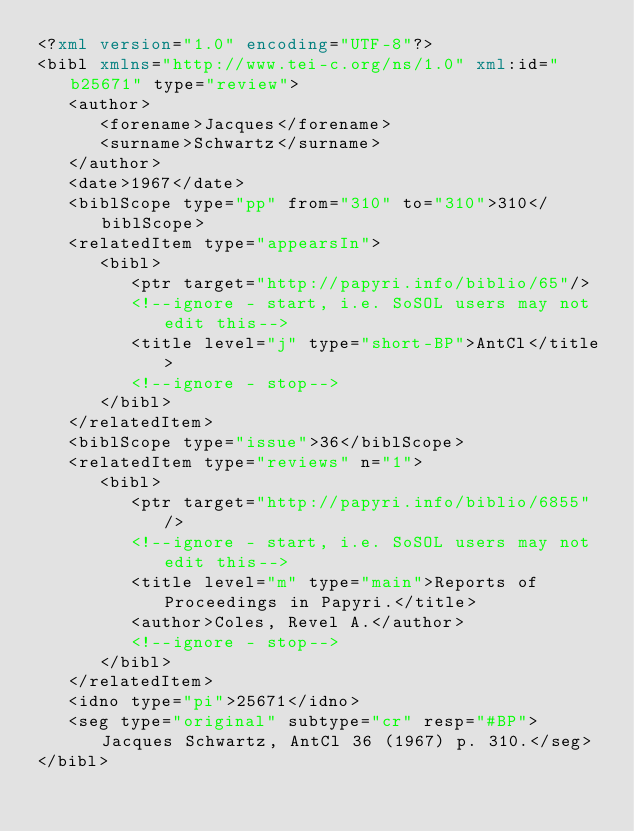Convert code to text. <code><loc_0><loc_0><loc_500><loc_500><_XML_><?xml version="1.0" encoding="UTF-8"?>
<bibl xmlns="http://www.tei-c.org/ns/1.0" xml:id="b25671" type="review">
   <author>
      <forename>Jacques</forename>
      <surname>Schwartz</surname>
   </author>
   <date>1967</date>
   <biblScope type="pp" from="310" to="310">310</biblScope>
   <relatedItem type="appearsIn">
      <bibl>
         <ptr target="http://papyri.info/biblio/65"/>
         <!--ignore - start, i.e. SoSOL users may not edit this-->
         <title level="j" type="short-BP">AntCl</title>
         <!--ignore - stop-->
      </bibl>
   </relatedItem>
   <biblScope type="issue">36</biblScope>
   <relatedItem type="reviews" n="1">
      <bibl>
         <ptr target="http://papyri.info/biblio/6855"/>
         <!--ignore - start, i.e. SoSOL users may not edit this-->
         <title level="m" type="main">Reports of Proceedings in Papyri.</title>
         <author>Coles, Revel A.</author>
         <!--ignore - stop-->
      </bibl>
   </relatedItem>
   <idno type="pi">25671</idno>
   <seg type="original" subtype="cr" resp="#BP">Jacques Schwartz, AntCl 36 (1967) p. 310.</seg>
</bibl>
</code> 